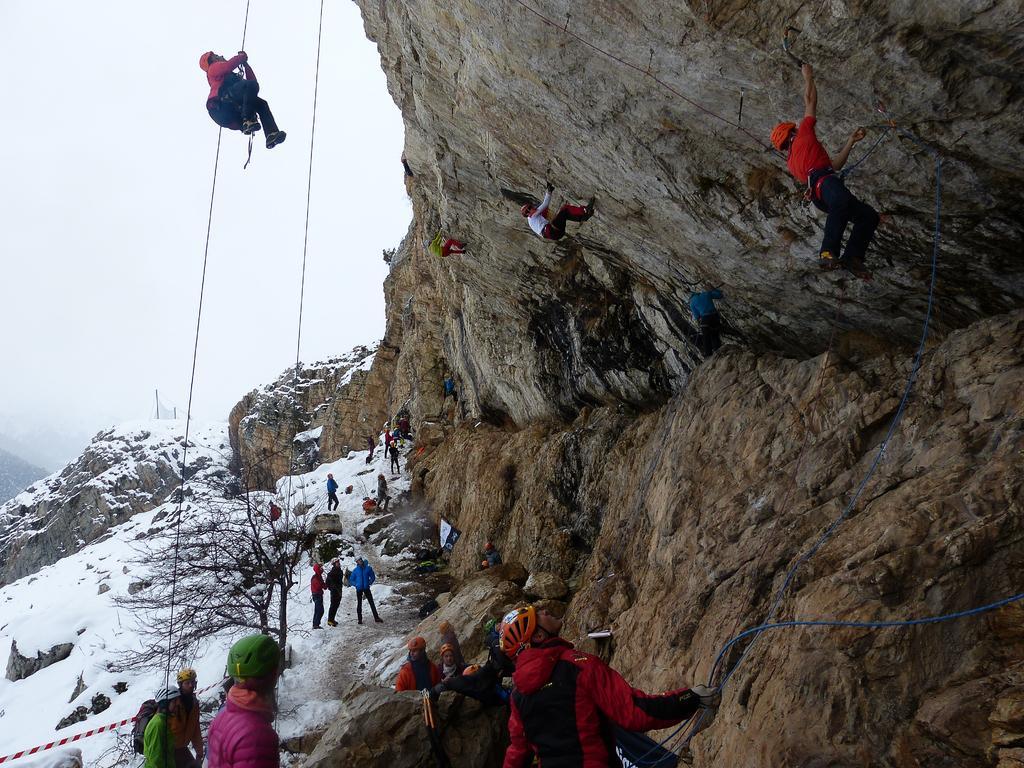In one or two sentences, can you explain what this image depicts? In this image there is the sky towards the top of the image, there are rocky mountains, there is ice, there is a tree, there are ropes, there are group of persons, there are persons climbing the rope, there is a man holding the rope towards the bottom of the image. 